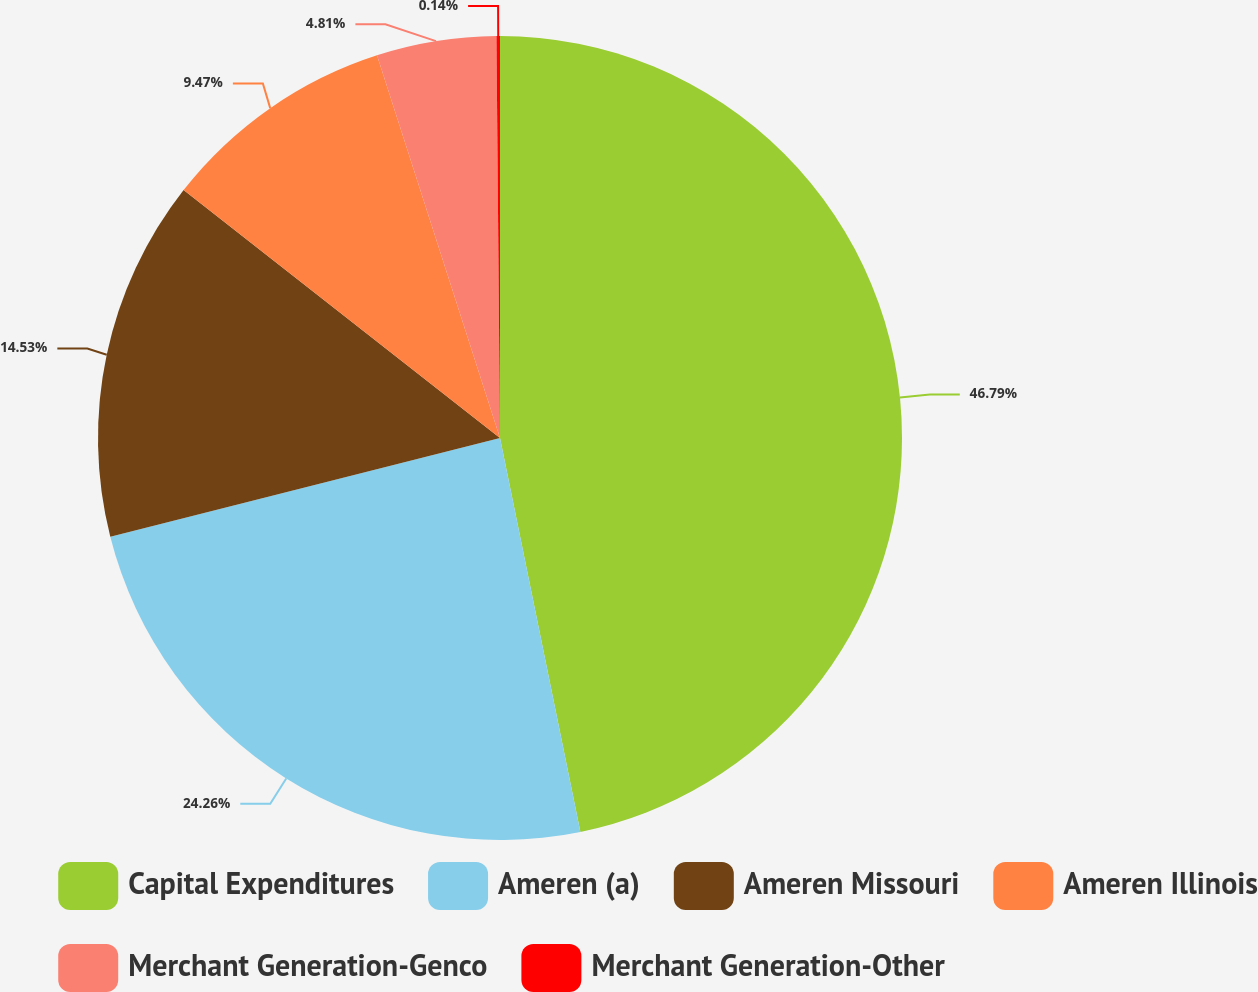Convert chart to OTSL. <chart><loc_0><loc_0><loc_500><loc_500><pie_chart><fcel>Capital Expenditures<fcel>Ameren (a)<fcel>Ameren Missouri<fcel>Ameren Illinois<fcel>Merchant Generation-Genco<fcel>Merchant Generation-Other<nl><fcel>46.8%<fcel>24.26%<fcel>14.53%<fcel>9.47%<fcel>4.81%<fcel>0.14%<nl></chart> 